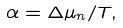Convert formula to latex. <formula><loc_0><loc_0><loc_500><loc_500>\alpha = \Delta \mu _ { n } / T ,</formula> 